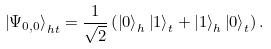Convert formula to latex. <formula><loc_0><loc_0><loc_500><loc_500>\left | \Psi _ { 0 , 0 } \right \rangle _ { h t } = \frac { 1 } { \sqrt { 2 } } \left ( \left | 0 \right \rangle _ { h } \left | 1 \right \rangle _ { t } + \left | 1 \right \rangle _ { h } \left | 0 \right \rangle _ { t } \right ) .</formula> 